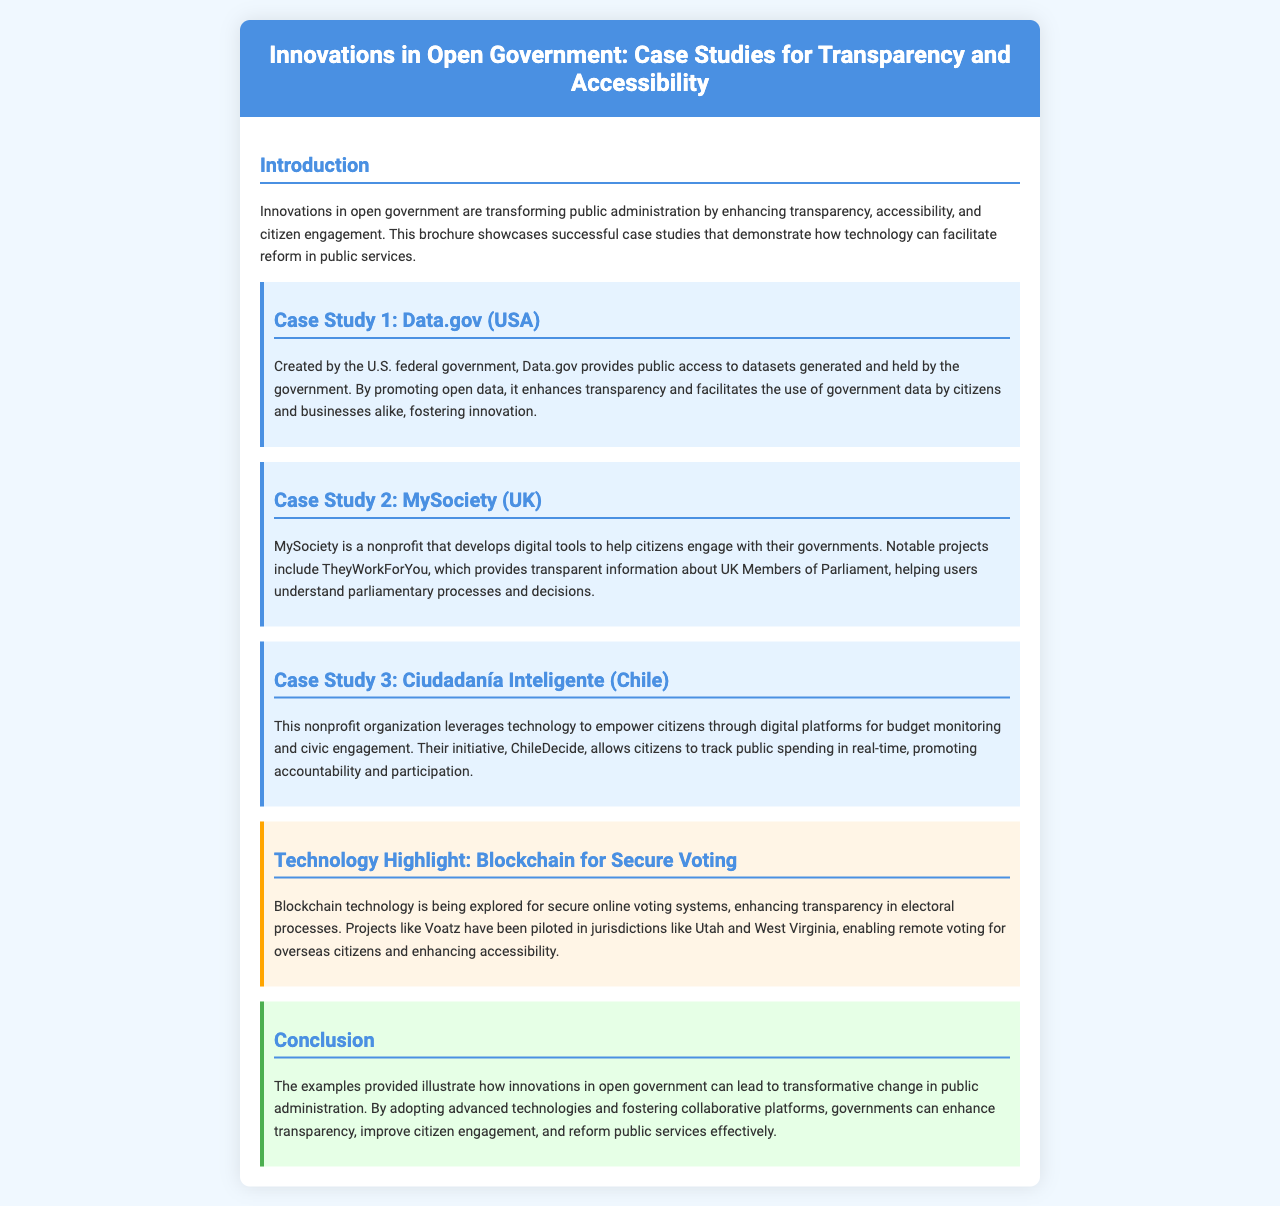what is the title of the brochure? The title is the main heading presented at the top of the brochure, summarizing its content focus.
Answer: Innovations in Open Government: Case Studies for Transparency and Accessibility how many case studies are mentioned? The brochure specifically lists three case studies that showcase different innovations in open government.
Answer: 3 who created Data.gov? The entity responsible for creating Data.gov is mentioned in the case study related to it.
Answer: U.S. federal government what does MySociety develop? The primary output of MySociety is described in the context of its function in supporting citizen engagement with government.
Answer: digital tools which technology is highlighted for secure voting? The document specifies a particular technology type being explored for enhancing the security of voting systems.
Answer: Blockchain what is the initiative of Ciudadanía Inteligente for tracking spending? The specific platform developed by Ciudadanía Inteligente aimed at enhancing civic engagement and accountability is named in the text.
Answer: ChileDecide what year did Data.gov get established? As the document does not specify the establishment year of Data.gov, this test is to highlight a missing but relevant detail that some readers might look for.
Answer: Not mentioned what is the main benefit of using Blockchain in voting? The document outlines a specific advantage of implementing this technology in electoral systems.
Answer: transparency 